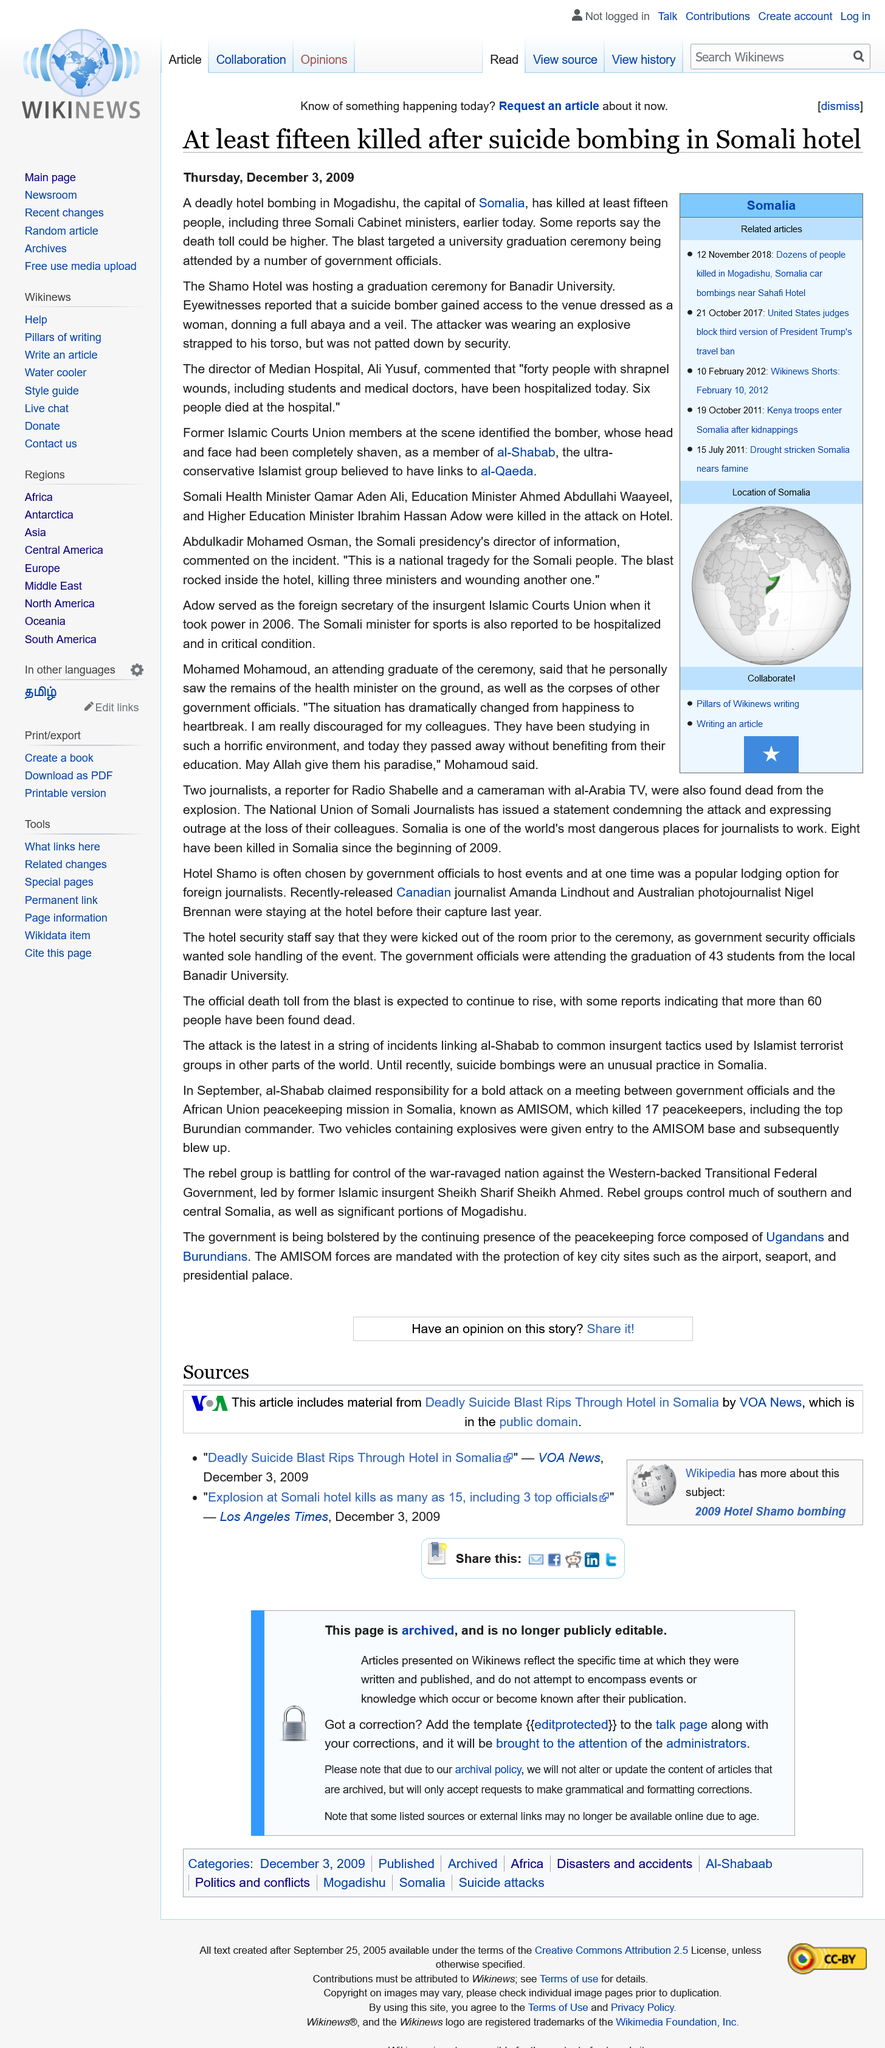Draw attention to some important aspects in this diagram. On April 4, 2023, in the city of Nairobi, Kenya, a terrorist attack occurred at The Shamo Hotel. It is declared that the bomber was not patted down by security at the event. During the terrorist attack in Somalia, three cabinet ministers lost their lives, while six people succumbed to their injuries in the hospital. 